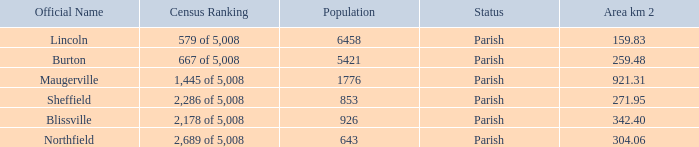What is the status(es) of the place with an area of 304.06 km2? Parish. 